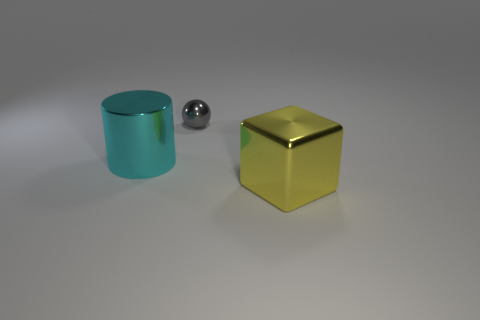Is there anything else that has the same size as the gray thing?
Provide a short and direct response. No. How many big objects are both right of the tiny gray shiny thing and to the left of the small ball?
Ensure brevity in your answer.  0. How many metal objects are either cyan cylinders or big red objects?
Keep it short and to the point. 1. There is a metallic thing in front of the big object left of the yellow metal object; what is its size?
Provide a short and direct response. Large. There is a large shiny thing that is to the left of the shiny object right of the gray sphere; are there any small gray objects on the left side of it?
Your response must be concise. No. What number of objects are either tiny brown cylinders or shiny objects that are on the right side of the small gray sphere?
Keep it short and to the point. 1. How many large things are the same shape as the tiny gray metallic object?
Your answer should be compact. 0. What is the size of the shiny thing on the right side of the small shiny object that is to the right of the thing that is to the left of the tiny gray metal object?
Provide a short and direct response. Large. What number of green objects are either shiny cylinders or metal things?
Offer a terse response. 0. How many metal objects are the same size as the cyan cylinder?
Ensure brevity in your answer.  1. 